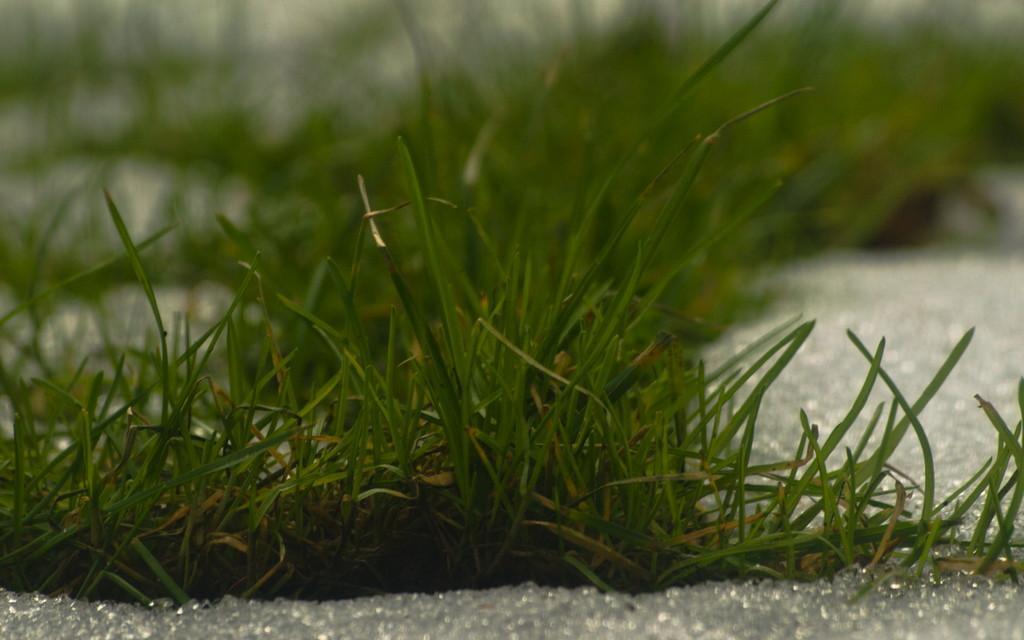Could you give a brief overview of what you see in this image? In this image I can see the green color grass on the ground. The background is blurred. 